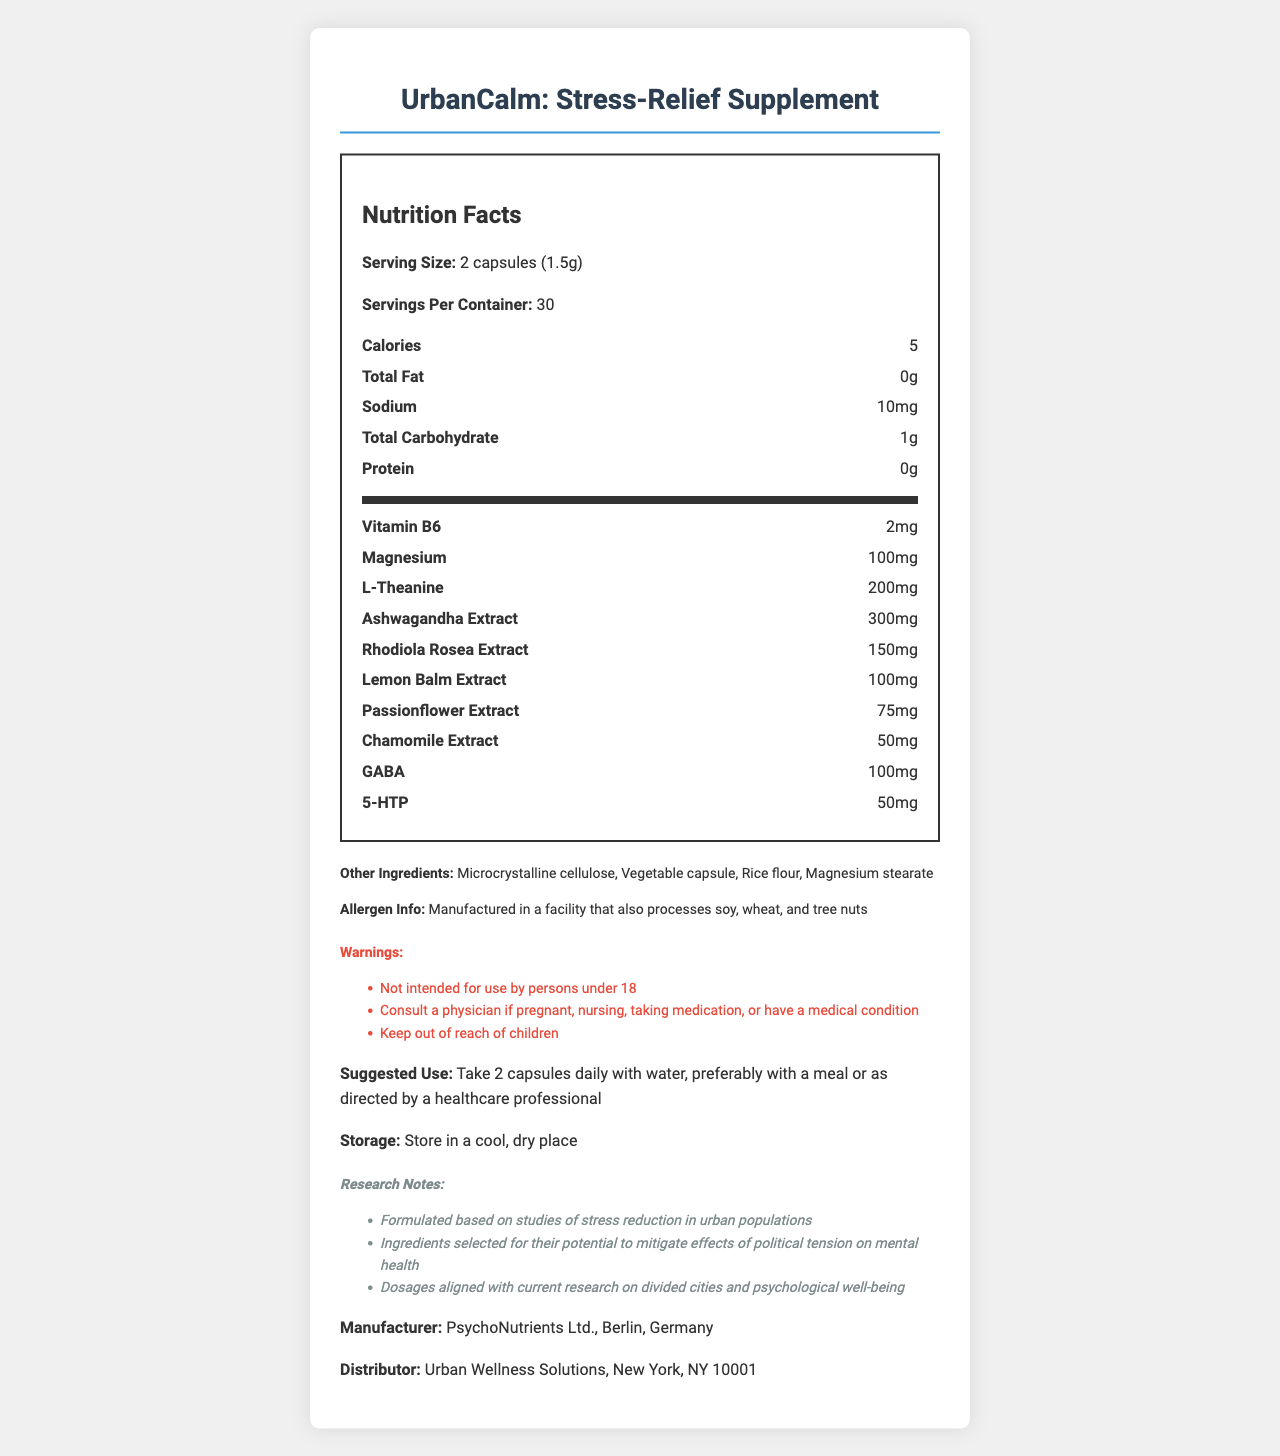what is the serving size of UrbanCalm: Stress-Relief Supplement? The document explicitly states the serving size as "2 capsules (1.5g)".
Answer: 2 capsules (1.5g) how many calories are in one serving of UrbanCalm? The document mentions that there are 5 calories per serving.
Answer: 5 how many mg of Ashwagandha Extract does each serving contain? The document lists "Ashwagandha Extract: 300mg" under the nutritional information.
Answer: 300mg what is the manufacturer of UrbanCalm: Stress-Relief Supplement? The document states that the manufacturer is "PsychoNutrients Ltd., Berlin, Germany".
Answer: PsychoNutrients Ltd., Berlin, Germany how should UrbanCalm: Stress-Relief Supplement be stored? The document specifies the storage instructions as "Store in a cool, dry place".
Answer: Store in a cool, dry place what allergens might be a concern with this supplement? The document includes an allergen info section that reads, "Manufactured in a facility that also processes soy, wheat, and tree nuts".
Answer: Soy, wheat, and tree nuts what is the suggested use for UrbanCalm? A. Take 1 capsule daily B. Take 2 capsules daily with water, preferably with a meal C. Consult a healthcare professional before taking D. Take 3 capsules daily with water The document includes a suggested use section that advises, "Take 2 capsules daily with water, preferably with a meal or as directed by a healthcare professional".
Answer: B which ingredient is present in the highest quantity per serving? A. GABA B. L-Theanine C. Ashwagandha Extract D. Rhodiola Rosea Extract The document lists "Ashwagandha Extract: 300mg", which is the highest amount compared to other ingredients per serving.
Answer: C is UrbanCalm intended for use by individuals under 18? The warnings section specifies, "Not intended for use by persons under 18".
Answer: No summarize the main purpose of UrbanCalm: Stress-Relief Supplement. The document provides information on the supplement's serving size, nutritional content, ingredients, suggested use, warnings, storage conditions, and supporting research. UrbanCalm aims to mitigate the effects of political tension on mental health.
Answer: UrbanCalm is a stress-relief supplement formulated specifically for residents of politically tense urban areas. It contains various extracts and compounds that are backed by research to reduce stress and improve mental well-being. The supplement is designed to be taken daily and includes clear usage instructions and warnings. what is the purpose of ingredients like L-Theanine and Rhodiola Rosea Extract in the supplement? The document lists these ingredients and their amounts but does not provide specific details about their purposes.
Answer: Not enough information how many servings are there in one container of UrbanCalm? According to the document, there are 30 servings per container.
Answer: 30 does the supplement contain any protein? The document specifically lists the protein content as "0g".
Answer: No what research notes are mentioned? The research notes section specifies that the formulation is based on studies of stress reduction in urban populations, ingredients were selected for mitigating the effects of political tension on mental health, and dosages were aligned with current research on divided cities and psychological well-being.
Answer: Formulated based on studies of stress reduction in urban populations 